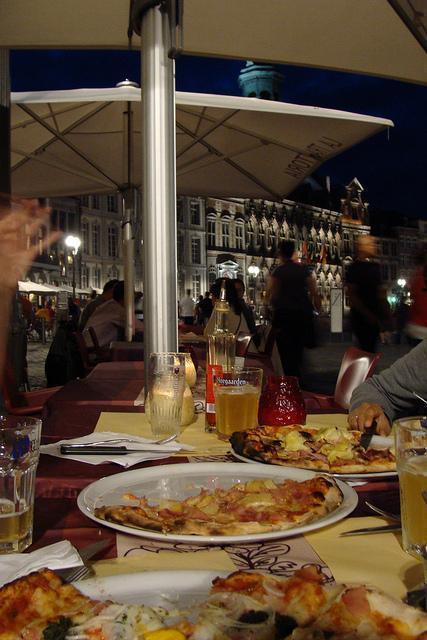How many people are there?
Give a very brief answer. 3. How many dining tables are there?
Give a very brief answer. 2. How many cups are there?
Give a very brief answer. 4. How many pizzas are there?
Give a very brief answer. 3. How many backpacks are in the picture?
Give a very brief answer. 1. How many bottles can be seen?
Give a very brief answer. 1. How many horses are laying down?
Give a very brief answer. 0. 